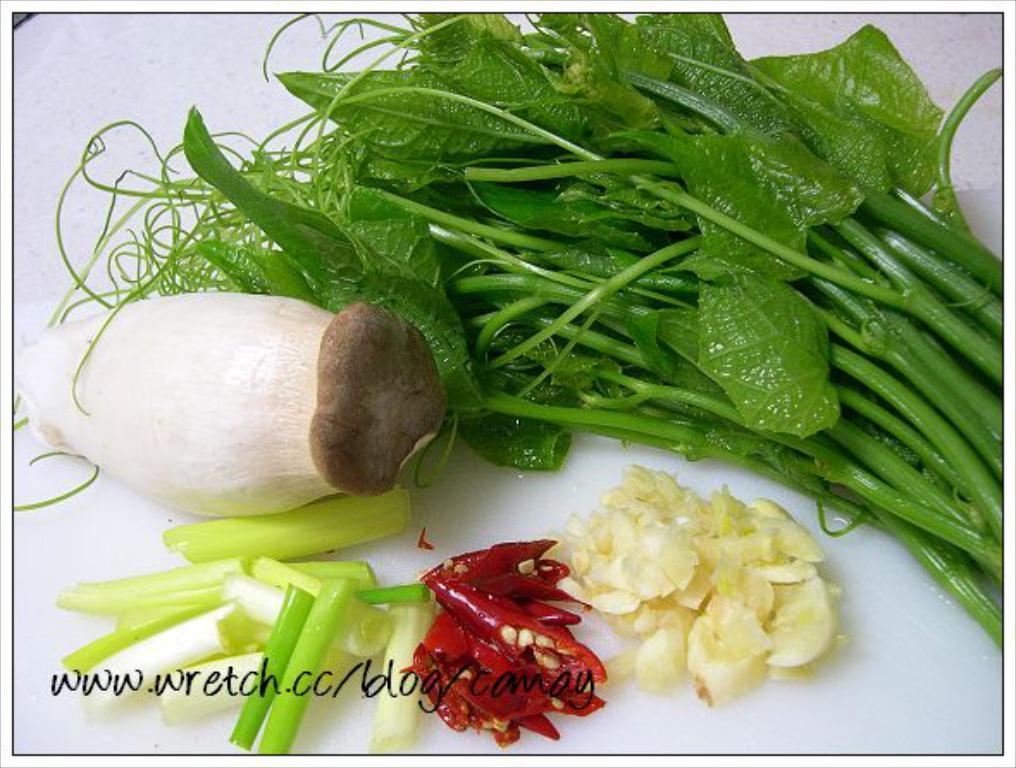In one or two sentences, can you explain what this image depicts? In this image, I can see a mushroom, chopped spring onions, leafy vegetable, chopped garlic and red chilies. This looks like a whiteboard. I can see the watermark on the image. 